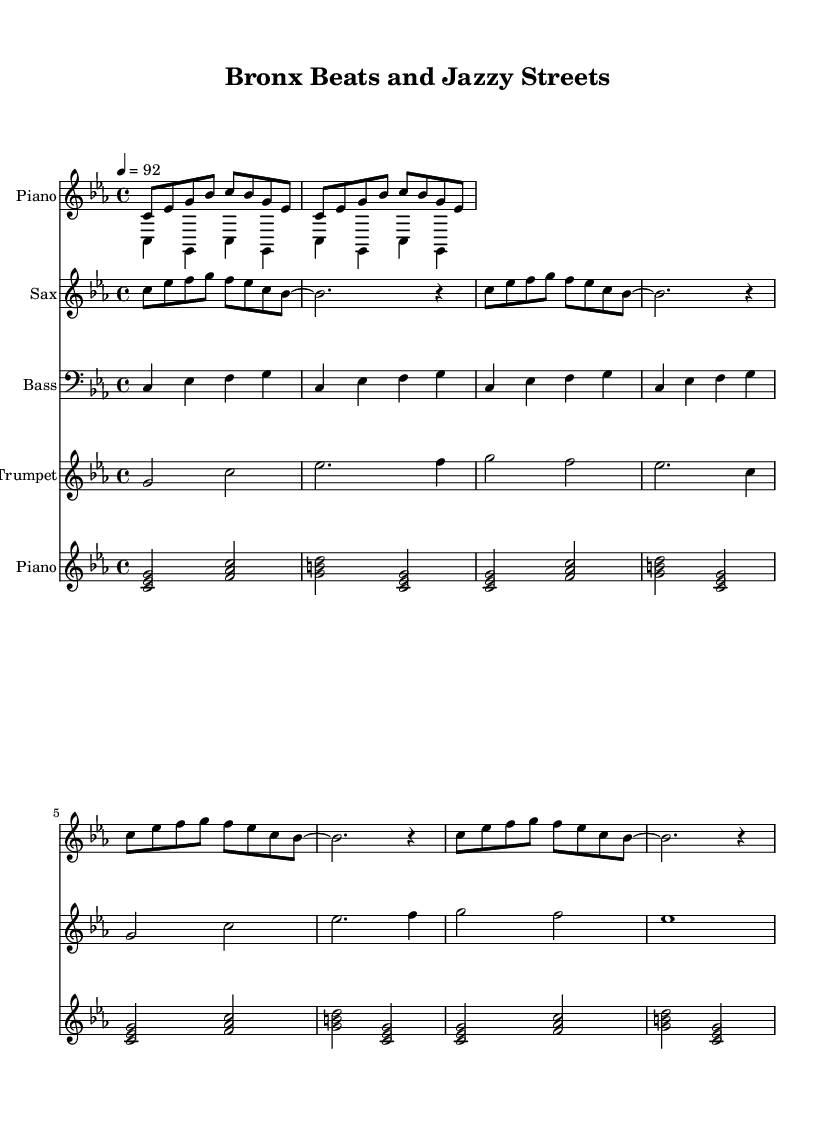What is the key signature of this music? The key signature indicated at the beginning of the sheet music shows C minor, which has three flats (B flat, E flat, and A flat).
Answer: C minor What is the time signature of this music? The time signature displayed at the start of the sheet music is 4/4, meaning there are four beats in each measure and the quarter note receives one beat.
Answer: 4/4 What is the tempo marking for this piece? The tempo marking at the top indicates a speed of 92 beats per minute, which suggests a moderately fast pace for the music.
Answer: 92 How many measures are in the intro piano section? The intro piano section has two repeated sets within the notation, making it a total of 2 measures, as each set is two measures long.
Answer: 2 What instruments are featured in this piece? The piece features Piano, Sax, Bass, and Trumpet as indicated by the identified staffs for each instrument within the score.
Answer: Piano, Sax, Bass, Trumpet In which section does the saxophone play next? The saxophone plays in the verse section, as indicated by the title and positioning of the staff within the score.
Answer: Verse What does the trumpet play in the chorus? The trumpet plays a series of two-note and one-note phrases throughout the chorus, specifically emphasizing G, C, E flat, and F as part of its melodic line.
Answer: G, C, E flat, F 